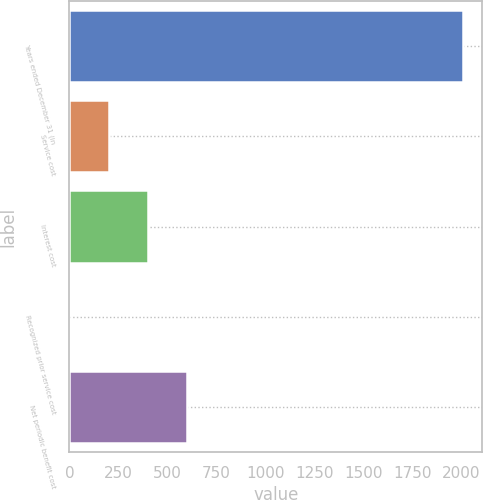<chart> <loc_0><loc_0><loc_500><loc_500><bar_chart><fcel>Years ended December 31 (in<fcel>Service cost<fcel>Interest cost<fcel>Recognized prior service cost<fcel>Net periodic benefit cost<nl><fcel>2006<fcel>200.69<fcel>401.28<fcel>0.1<fcel>601.87<nl></chart> 